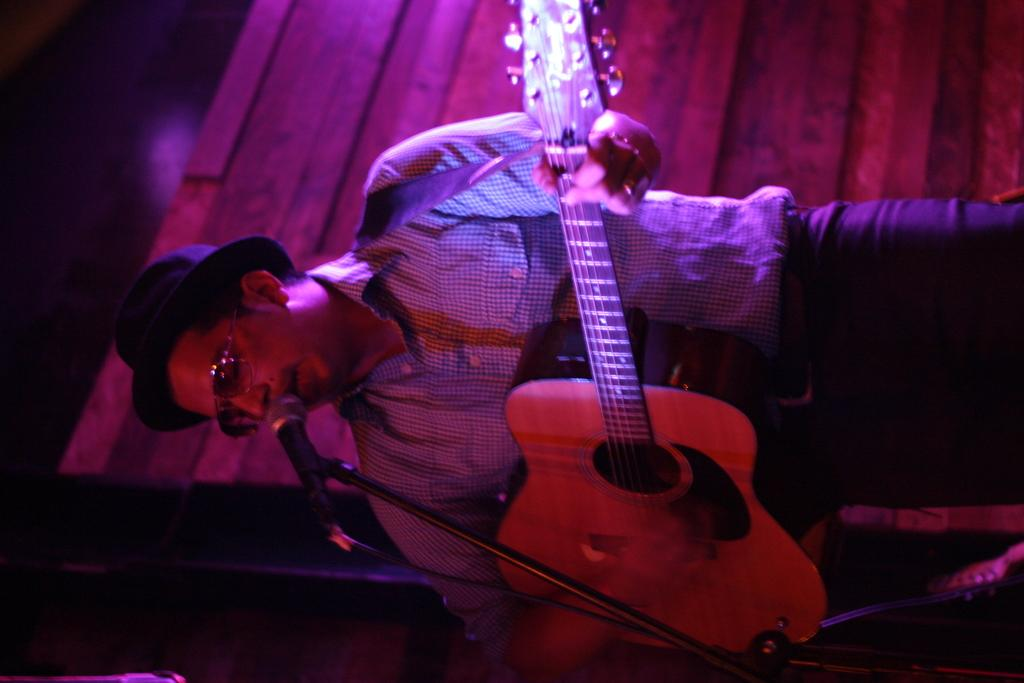Who is the main subject in the image? There is a man in the image. What is the man holding in the image? The man is holding a guitar. What is the man doing with the guitar? The man is singing a song. How is the man's voice being amplified in the image? The man is using a microphone. What type of lace is draped over the man's guitar in the image? There is no lace draped over the man's guitar in the image. What form does the man's guitar take in the image? The man's guitar is in its standard, recognizable form. 